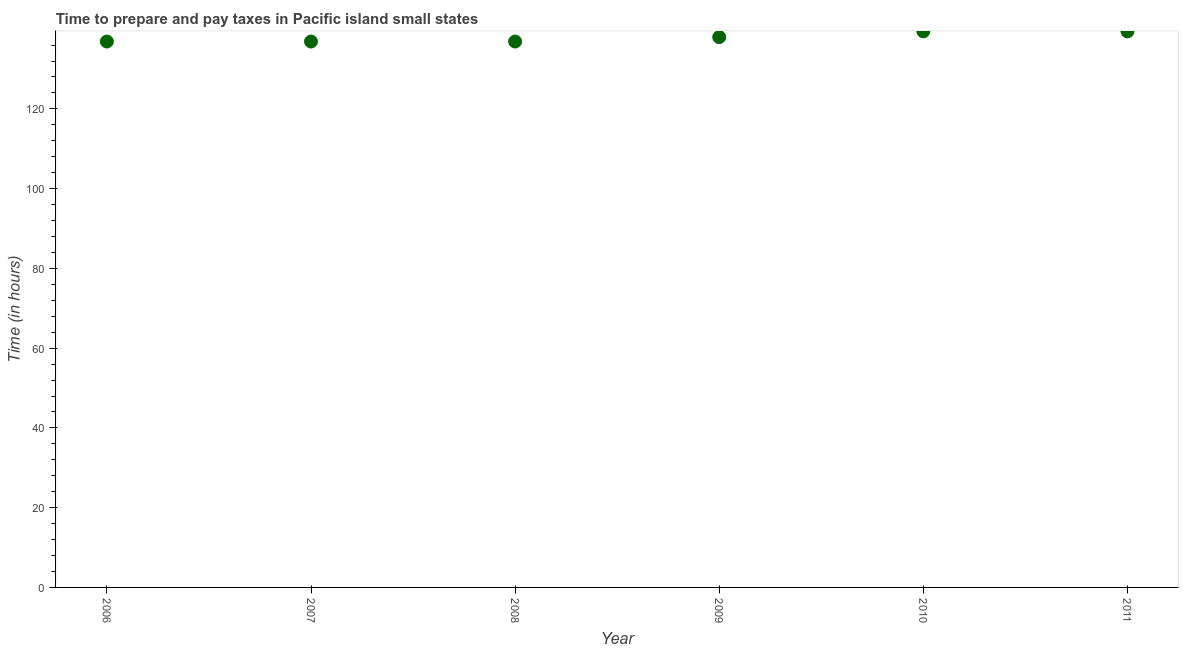What is the time to prepare and pay taxes in 2009?
Provide a short and direct response. 138. Across all years, what is the maximum time to prepare and pay taxes?
Make the answer very short. 139.44. Across all years, what is the minimum time to prepare and pay taxes?
Provide a succinct answer. 136.89. In which year was the time to prepare and pay taxes maximum?
Your answer should be very brief. 2010. In which year was the time to prepare and pay taxes minimum?
Give a very brief answer. 2006. What is the sum of the time to prepare and pay taxes?
Give a very brief answer. 827.56. What is the difference between the time to prepare and pay taxes in 2006 and 2011?
Your answer should be compact. -2.56. What is the average time to prepare and pay taxes per year?
Offer a very short reply. 137.93. What is the median time to prepare and pay taxes?
Offer a very short reply. 137.44. What is the ratio of the time to prepare and pay taxes in 2006 to that in 2010?
Your answer should be very brief. 0.98. Is the difference between the time to prepare and pay taxes in 2008 and 2010 greater than the difference between any two years?
Offer a very short reply. Yes. What is the difference between the highest and the lowest time to prepare and pay taxes?
Your answer should be compact. 2.56. In how many years, is the time to prepare and pay taxes greater than the average time to prepare and pay taxes taken over all years?
Your response must be concise. 3. How many dotlines are there?
Provide a succinct answer. 1. Are the values on the major ticks of Y-axis written in scientific E-notation?
Ensure brevity in your answer.  No. Does the graph contain grids?
Provide a succinct answer. No. What is the title of the graph?
Offer a terse response. Time to prepare and pay taxes in Pacific island small states. What is the label or title of the Y-axis?
Provide a short and direct response. Time (in hours). What is the Time (in hours) in 2006?
Your answer should be compact. 136.89. What is the Time (in hours) in 2007?
Provide a short and direct response. 136.89. What is the Time (in hours) in 2008?
Offer a terse response. 136.89. What is the Time (in hours) in 2009?
Keep it short and to the point. 138. What is the Time (in hours) in 2010?
Keep it short and to the point. 139.44. What is the Time (in hours) in 2011?
Your response must be concise. 139.44. What is the difference between the Time (in hours) in 2006 and 2007?
Offer a very short reply. 0. What is the difference between the Time (in hours) in 2006 and 2009?
Ensure brevity in your answer.  -1.11. What is the difference between the Time (in hours) in 2006 and 2010?
Your answer should be very brief. -2.56. What is the difference between the Time (in hours) in 2006 and 2011?
Your response must be concise. -2.56. What is the difference between the Time (in hours) in 2007 and 2008?
Provide a succinct answer. 0. What is the difference between the Time (in hours) in 2007 and 2009?
Give a very brief answer. -1.11. What is the difference between the Time (in hours) in 2007 and 2010?
Ensure brevity in your answer.  -2.56. What is the difference between the Time (in hours) in 2007 and 2011?
Make the answer very short. -2.56. What is the difference between the Time (in hours) in 2008 and 2009?
Offer a very short reply. -1.11. What is the difference between the Time (in hours) in 2008 and 2010?
Make the answer very short. -2.56. What is the difference between the Time (in hours) in 2008 and 2011?
Make the answer very short. -2.56. What is the difference between the Time (in hours) in 2009 and 2010?
Provide a short and direct response. -1.44. What is the difference between the Time (in hours) in 2009 and 2011?
Ensure brevity in your answer.  -1.44. What is the difference between the Time (in hours) in 2010 and 2011?
Your answer should be compact. 0. What is the ratio of the Time (in hours) in 2006 to that in 2007?
Offer a very short reply. 1. What is the ratio of the Time (in hours) in 2006 to that in 2008?
Make the answer very short. 1. What is the ratio of the Time (in hours) in 2006 to that in 2009?
Ensure brevity in your answer.  0.99. What is the ratio of the Time (in hours) in 2006 to that in 2011?
Your response must be concise. 0.98. What is the ratio of the Time (in hours) in 2007 to that in 2009?
Your answer should be compact. 0.99. What is the ratio of the Time (in hours) in 2007 to that in 2011?
Make the answer very short. 0.98. What is the ratio of the Time (in hours) in 2008 to that in 2010?
Your response must be concise. 0.98. What is the ratio of the Time (in hours) in 2009 to that in 2011?
Provide a succinct answer. 0.99. What is the ratio of the Time (in hours) in 2010 to that in 2011?
Make the answer very short. 1. 